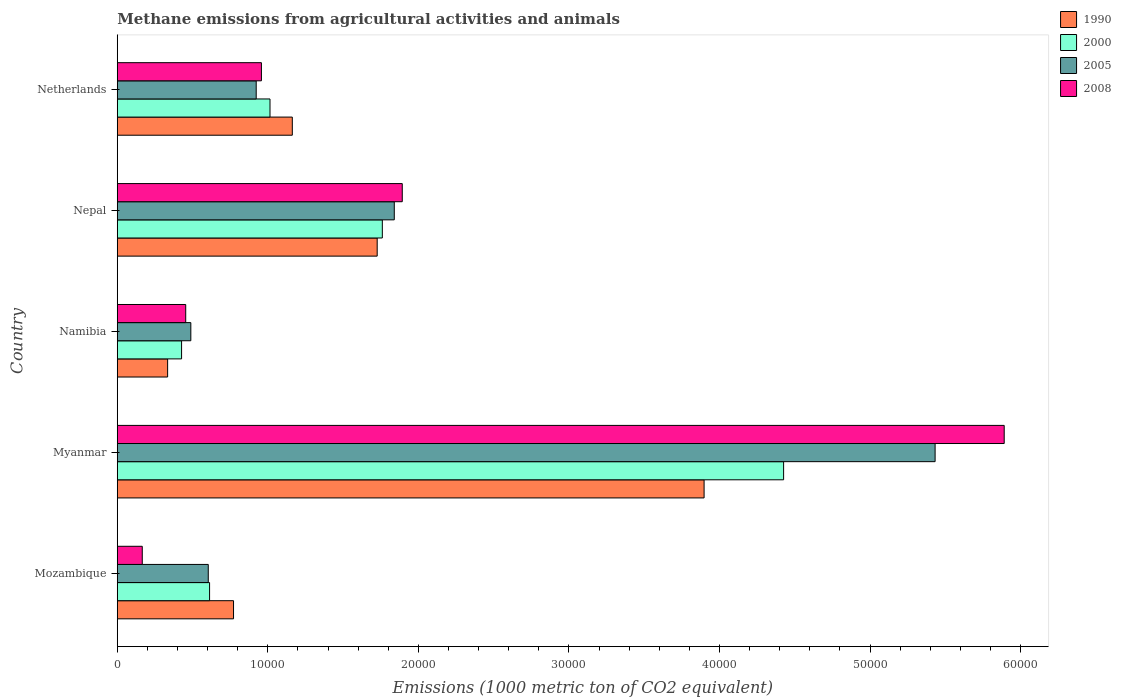How many groups of bars are there?
Your answer should be compact. 5. Are the number of bars on each tick of the Y-axis equal?
Offer a terse response. Yes. How many bars are there on the 4th tick from the top?
Make the answer very short. 4. How many bars are there on the 2nd tick from the bottom?
Offer a terse response. 4. What is the label of the 4th group of bars from the top?
Make the answer very short. Myanmar. In how many cases, is the number of bars for a given country not equal to the number of legend labels?
Your answer should be very brief. 0. What is the amount of methane emitted in 2005 in Mozambique?
Make the answer very short. 6043.9. Across all countries, what is the maximum amount of methane emitted in 2005?
Your response must be concise. 5.43e+04. Across all countries, what is the minimum amount of methane emitted in 1990?
Your answer should be very brief. 3344.1. In which country was the amount of methane emitted in 1990 maximum?
Keep it short and to the point. Myanmar. In which country was the amount of methane emitted in 2008 minimum?
Provide a succinct answer. Mozambique. What is the total amount of methane emitted in 2005 in the graph?
Offer a very short reply. 9.29e+04. What is the difference between the amount of methane emitted in 2008 in Mozambique and that in Myanmar?
Make the answer very short. -5.73e+04. What is the difference between the amount of methane emitted in 2005 in Namibia and the amount of methane emitted in 2008 in Myanmar?
Your answer should be very brief. -5.40e+04. What is the average amount of methane emitted in 2000 per country?
Keep it short and to the point. 1.65e+04. What is the difference between the amount of methane emitted in 2008 and amount of methane emitted in 1990 in Mozambique?
Keep it short and to the point. -6062.1. In how many countries, is the amount of methane emitted in 2005 greater than 22000 1000 metric ton?
Provide a succinct answer. 1. What is the ratio of the amount of methane emitted in 1990 in Namibia to that in Netherlands?
Offer a terse response. 0.29. What is the difference between the highest and the second highest amount of methane emitted in 2005?
Provide a succinct answer. 3.59e+04. What is the difference between the highest and the lowest amount of methane emitted in 2008?
Offer a terse response. 5.73e+04. In how many countries, is the amount of methane emitted in 2000 greater than the average amount of methane emitted in 2000 taken over all countries?
Make the answer very short. 2. What does the 3rd bar from the top in Nepal represents?
Your answer should be compact. 2000. How many bars are there?
Offer a very short reply. 20. What is the difference between two consecutive major ticks on the X-axis?
Give a very brief answer. 10000. Are the values on the major ticks of X-axis written in scientific E-notation?
Ensure brevity in your answer.  No. Does the graph contain grids?
Give a very brief answer. No. How many legend labels are there?
Your answer should be very brief. 4. What is the title of the graph?
Provide a succinct answer. Methane emissions from agricultural activities and animals. What is the label or title of the X-axis?
Give a very brief answer. Emissions (1000 metric ton of CO2 equivalent). What is the label or title of the Y-axis?
Make the answer very short. Country. What is the Emissions (1000 metric ton of CO2 equivalent) in 1990 in Mozambique?
Give a very brief answer. 7721.4. What is the Emissions (1000 metric ton of CO2 equivalent) of 2000 in Mozambique?
Provide a short and direct response. 6130.9. What is the Emissions (1000 metric ton of CO2 equivalent) in 2005 in Mozambique?
Offer a very short reply. 6043.9. What is the Emissions (1000 metric ton of CO2 equivalent) in 2008 in Mozambique?
Provide a succinct answer. 1659.3. What is the Emissions (1000 metric ton of CO2 equivalent) in 1990 in Myanmar?
Your response must be concise. 3.90e+04. What is the Emissions (1000 metric ton of CO2 equivalent) in 2000 in Myanmar?
Make the answer very short. 4.43e+04. What is the Emissions (1000 metric ton of CO2 equivalent) in 2005 in Myanmar?
Ensure brevity in your answer.  5.43e+04. What is the Emissions (1000 metric ton of CO2 equivalent) in 2008 in Myanmar?
Ensure brevity in your answer.  5.89e+04. What is the Emissions (1000 metric ton of CO2 equivalent) in 1990 in Namibia?
Your answer should be compact. 3344.1. What is the Emissions (1000 metric ton of CO2 equivalent) in 2000 in Namibia?
Offer a terse response. 4271.2. What is the Emissions (1000 metric ton of CO2 equivalent) of 2005 in Namibia?
Your answer should be very brief. 4885.4. What is the Emissions (1000 metric ton of CO2 equivalent) of 2008 in Namibia?
Provide a short and direct response. 4545.9. What is the Emissions (1000 metric ton of CO2 equivalent) in 1990 in Nepal?
Your response must be concise. 1.73e+04. What is the Emissions (1000 metric ton of CO2 equivalent) in 2000 in Nepal?
Your response must be concise. 1.76e+04. What is the Emissions (1000 metric ton of CO2 equivalent) of 2005 in Nepal?
Your answer should be very brief. 1.84e+04. What is the Emissions (1000 metric ton of CO2 equivalent) of 2008 in Nepal?
Keep it short and to the point. 1.89e+04. What is the Emissions (1000 metric ton of CO2 equivalent) in 1990 in Netherlands?
Offer a very short reply. 1.16e+04. What is the Emissions (1000 metric ton of CO2 equivalent) in 2000 in Netherlands?
Offer a terse response. 1.01e+04. What is the Emissions (1000 metric ton of CO2 equivalent) of 2005 in Netherlands?
Provide a succinct answer. 9228. What is the Emissions (1000 metric ton of CO2 equivalent) in 2008 in Netherlands?
Make the answer very short. 9574.5. Across all countries, what is the maximum Emissions (1000 metric ton of CO2 equivalent) in 1990?
Ensure brevity in your answer.  3.90e+04. Across all countries, what is the maximum Emissions (1000 metric ton of CO2 equivalent) in 2000?
Keep it short and to the point. 4.43e+04. Across all countries, what is the maximum Emissions (1000 metric ton of CO2 equivalent) in 2005?
Your answer should be very brief. 5.43e+04. Across all countries, what is the maximum Emissions (1000 metric ton of CO2 equivalent) of 2008?
Make the answer very short. 5.89e+04. Across all countries, what is the minimum Emissions (1000 metric ton of CO2 equivalent) of 1990?
Provide a short and direct response. 3344.1. Across all countries, what is the minimum Emissions (1000 metric ton of CO2 equivalent) in 2000?
Offer a very short reply. 4271.2. Across all countries, what is the minimum Emissions (1000 metric ton of CO2 equivalent) in 2005?
Keep it short and to the point. 4885.4. Across all countries, what is the minimum Emissions (1000 metric ton of CO2 equivalent) of 2008?
Your response must be concise. 1659.3. What is the total Emissions (1000 metric ton of CO2 equivalent) in 1990 in the graph?
Make the answer very short. 7.89e+04. What is the total Emissions (1000 metric ton of CO2 equivalent) in 2000 in the graph?
Provide a succinct answer. 8.24e+04. What is the total Emissions (1000 metric ton of CO2 equivalent) of 2005 in the graph?
Offer a terse response. 9.29e+04. What is the total Emissions (1000 metric ton of CO2 equivalent) of 2008 in the graph?
Keep it short and to the point. 9.36e+04. What is the difference between the Emissions (1000 metric ton of CO2 equivalent) in 1990 in Mozambique and that in Myanmar?
Your response must be concise. -3.13e+04. What is the difference between the Emissions (1000 metric ton of CO2 equivalent) of 2000 in Mozambique and that in Myanmar?
Your answer should be compact. -3.81e+04. What is the difference between the Emissions (1000 metric ton of CO2 equivalent) in 2005 in Mozambique and that in Myanmar?
Make the answer very short. -4.83e+04. What is the difference between the Emissions (1000 metric ton of CO2 equivalent) of 2008 in Mozambique and that in Myanmar?
Provide a succinct answer. -5.73e+04. What is the difference between the Emissions (1000 metric ton of CO2 equivalent) of 1990 in Mozambique and that in Namibia?
Offer a terse response. 4377.3. What is the difference between the Emissions (1000 metric ton of CO2 equivalent) of 2000 in Mozambique and that in Namibia?
Your answer should be compact. 1859.7. What is the difference between the Emissions (1000 metric ton of CO2 equivalent) in 2005 in Mozambique and that in Namibia?
Provide a short and direct response. 1158.5. What is the difference between the Emissions (1000 metric ton of CO2 equivalent) of 2008 in Mozambique and that in Namibia?
Your answer should be very brief. -2886.6. What is the difference between the Emissions (1000 metric ton of CO2 equivalent) of 1990 in Mozambique and that in Nepal?
Give a very brief answer. -9542.8. What is the difference between the Emissions (1000 metric ton of CO2 equivalent) in 2000 in Mozambique and that in Nepal?
Offer a very short reply. -1.15e+04. What is the difference between the Emissions (1000 metric ton of CO2 equivalent) of 2005 in Mozambique and that in Nepal?
Provide a succinct answer. -1.24e+04. What is the difference between the Emissions (1000 metric ton of CO2 equivalent) in 2008 in Mozambique and that in Nepal?
Your answer should be very brief. -1.73e+04. What is the difference between the Emissions (1000 metric ton of CO2 equivalent) in 1990 in Mozambique and that in Netherlands?
Your answer should be very brief. -3904.6. What is the difference between the Emissions (1000 metric ton of CO2 equivalent) of 2000 in Mozambique and that in Netherlands?
Keep it short and to the point. -4013.9. What is the difference between the Emissions (1000 metric ton of CO2 equivalent) in 2005 in Mozambique and that in Netherlands?
Provide a succinct answer. -3184.1. What is the difference between the Emissions (1000 metric ton of CO2 equivalent) in 2008 in Mozambique and that in Netherlands?
Provide a succinct answer. -7915.2. What is the difference between the Emissions (1000 metric ton of CO2 equivalent) of 1990 in Myanmar and that in Namibia?
Offer a terse response. 3.56e+04. What is the difference between the Emissions (1000 metric ton of CO2 equivalent) of 2000 in Myanmar and that in Namibia?
Give a very brief answer. 4.00e+04. What is the difference between the Emissions (1000 metric ton of CO2 equivalent) in 2005 in Myanmar and that in Namibia?
Keep it short and to the point. 4.94e+04. What is the difference between the Emissions (1000 metric ton of CO2 equivalent) in 2008 in Myanmar and that in Namibia?
Keep it short and to the point. 5.44e+04. What is the difference between the Emissions (1000 metric ton of CO2 equivalent) in 1990 in Myanmar and that in Nepal?
Keep it short and to the point. 2.17e+04. What is the difference between the Emissions (1000 metric ton of CO2 equivalent) of 2000 in Myanmar and that in Nepal?
Give a very brief answer. 2.67e+04. What is the difference between the Emissions (1000 metric ton of CO2 equivalent) in 2005 in Myanmar and that in Nepal?
Provide a short and direct response. 3.59e+04. What is the difference between the Emissions (1000 metric ton of CO2 equivalent) of 2008 in Myanmar and that in Nepal?
Provide a succinct answer. 4.00e+04. What is the difference between the Emissions (1000 metric ton of CO2 equivalent) of 1990 in Myanmar and that in Netherlands?
Your answer should be very brief. 2.74e+04. What is the difference between the Emissions (1000 metric ton of CO2 equivalent) of 2000 in Myanmar and that in Netherlands?
Your answer should be compact. 3.41e+04. What is the difference between the Emissions (1000 metric ton of CO2 equivalent) of 2005 in Myanmar and that in Netherlands?
Offer a very short reply. 4.51e+04. What is the difference between the Emissions (1000 metric ton of CO2 equivalent) of 2008 in Myanmar and that in Netherlands?
Offer a very short reply. 4.93e+04. What is the difference between the Emissions (1000 metric ton of CO2 equivalent) of 1990 in Namibia and that in Nepal?
Your answer should be compact. -1.39e+04. What is the difference between the Emissions (1000 metric ton of CO2 equivalent) of 2000 in Namibia and that in Nepal?
Offer a terse response. -1.33e+04. What is the difference between the Emissions (1000 metric ton of CO2 equivalent) in 2005 in Namibia and that in Nepal?
Offer a very short reply. -1.35e+04. What is the difference between the Emissions (1000 metric ton of CO2 equivalent) of 2008 in Namibia and that in Nepal?
Provide a short and direct response. -1.44e+04. What is the difference between the Emissions (1000 metric ton of CO2 equivalent) in 1990 in Namibia and that in Netherlands?
Keep it short and to the point. -8281.9. What is the difference between the Emissions (1000 metric ton of CO2 equivalent) in 2000 in Namibia and that in Netherlands?
Provide a succinct answer. -5873.6. What is the difference between the Emissions (1000 metric ton of CO2 equivalent) in 2005 in Namibia and that in Netherlands?
Offer a terse response. -4342.6. What is the difference between the Emissions (1000 metric ton of CO2 equivalent) of 2008 in Namibia and that in Netherlands?
Provide a succinct answer. -5028.6. What is the difference between the Emissions (1000 metric ton of CO2 equivalent) in 1990 in Nepal and that in Netherlands?
Ensure brevity in your answer.  5638.2. What is the difference between the Emissions (1000 metric ton of CO2 equivalent) in 2000 in Nepal and that in Netherlands?
Provide a short and direct response. 7461.2. What is the difference between the Emissions (1000 metric ton of CO2 equivalent) of 2005 in Nepal and that in Netherlands?
Offer a terse response. 9171.3. What is the difference between the Emissions (1000 metric ton of CO2 equivalent) in 2008 in Nepal and that in Netherlands?
Provide a short and direct response. 9355.9. What is the difference between the Emissions (1000 metric ton of CO2 equivalent) in 1990 in Mozambique and the Emissions (1000 metric ton of CO2 equivalent) in 2000 in Myanmar?
Provide a succinct answer. -3.65e+04. What is the difference between the Emissions (1000 metric ton of CO2 equivalent) in 1990 in Mozambique and the Emissions (1000 metric ton of CO2 equivalent) in 2005 in Myanmar?
Your answer should be compact. -4.66e+04. What is the difference between the Emissions (1000 metric ton of CO2 equivalent) in 1990 in Mozambique and the Emissions (1000 metric ton of CO2 equivalent) in 2008 in Myanmar?
Your response must be concise. -5.12e+04. What is the difference between the Emissions (1000 metric ton of CO2 equivalent) of 2000 in Mozambique and the Emissions (1000 metric ton of CO2 equivalent) of 2005 in Myanmar?
Keep it short and to the point. -4.82e+04. What is the difference between the Emissions (1000 metric ton of CO2 equivalent) of 2000 in Mozambique and the Emissions (1000 metric ton of CO2 equivalent) of 2008 in Myanmar?
Ensure brevity in your answer.  -5.28e+04. What is the difference between the Emissions (1000 metric ton of CO2 equivalent) in 2005 in Mozambique and the Emissions (1000 metric ton of CO2 equivalent) in 2008 in Myanmar?
Offer a very short reply. -5.29e+04. What is the difference between the Emissions (1000 metric ton of CO2 equivalent) in 1990 in Mozambique and the Emissions (1000 metric ton of CO2 equivalent) in 2000 in Namibia?
Keep it short and to the point. 3450.2. What is the difference between the Emissions (1000 metric ton of CO2 equivalent) in 1990 in Mozambique and the Emissions (1000 metric ton of CO2 equivalent) in 2005 in Namibia?
Keep it short and to the point. 2836. What is the difference between the Emissions (1000 metric ton of CO2 equivalent) in 1990 in Mozambique and the Emissions (1000 metric ton of CO2 equivalent) in 2008 in Namibia?
Your answer should be compact. 3175.5. What is the difference between the Emissions (1000 metric ton of CO2 equivalent) in 2000 in Mozambique and the Emissions (1000 metric ton of CO2 equivalent) in 2005 in Namibia?
Give a very brief answer. 1245.5. What is the difference between the Emissions (1000 metric ton of CO2 equivalent) of 2000 in Mozambique and the Emissions (1000 metric ton of CO2 equivalent) of 2008 in Namibia?
Give a very brief answer. 1585. What is the difference between the Emissions (1000 metric ton of CO2 equivalent) in 2005 in Mozambique and the Emissions (1000 metric ton of CO2 equivalent) in 2008 in Namibia?
Your response must be concise. 1498. What is the difference between the Emissions (1000 metric ton of CO2 equivalent) in 1990 in Mozambique and the Emissions (1000 metric ton of CO2 equivalent) in 2000 in Nepal?
Give a very brief answer. -9884.6. What is the difference between the Emissions (1000 metric ton of CO2 equivalent) in 1990 in Mozambique and the Emissions (1000 metric ton of CO2 equivalent) in 2005 in Nepal?
Provide a succinct answer. -1.07e+04. What is the difference between the Emissions (1000 metric ton of CO2 equivalent) in 1990 in Mozambique and the Emissions (1000 metric ton of CO2 equivalent) in 2008 in Nepal?
Make the answer very short. -1.12e+04. What is the difference between the Emissions (1000 metric ton of CO2 equivalent) in 2000 in Mozambique and the Emissions (1000 metric ton of CO2 equivalent) in 2005 in Nepal?
Provide a succinct answer. -1.23e+04. What is the difference between the Emissions (1000 metric ton of CO2 equivalent) in 2000 in Mozambique and the Emissions (1000 metric ton of CO2 equivalent) in 2008 in Nepal?
Provide a succinct answer. -1.28e+04. What is the difference between the Emissions (1000 metric ton of CO2 equivalent) in 2005 in Mozambique and the Emissions (1000 metric ton of CO2 equivalent) in 2008 in Nepal?
Ensure brevity in your answer.  -1.29e+04. What is the difference between the Emissions (1000 metric ton of CO2 equivalent) in 1990 in Mozambique and the Emissions (1000 metric ton of CO2 equivalent) in 2000 in Netherlands?
Your answer should be compact. -2423.4. What is the difference between the Emissions (1000 metric ton of CO2 equivalent) of 1990 in Mozambique and the Emissions (1000 metric ton of CO2 equivalent) of 2005 in Netherlands?
Your response must be concise. -1506.6. What is the difference between the Emissions (1000 metric ton of CO2 equivalent) in 1990 in Mozambique and the Emissions (1000 metric ton of CO2 equivalent) in 2008 in Netherlands?
Your response must be concise. -1853.1. What is the difference between the Emissions (1000 metric ton of CO2 equivalent) in 2000 in Mozambique and the Emissions (1000 metric ton of CO2 equivalent) in 2005 in Netherlands?
Provide a succinct answer. -3097.1. What is the difference between the Emissions (1000 metric ton of CO2 equivalent) in 2000 in Mozambique and the Emissions (1000 metric ton of CO2 equivalent) in 2008 in Netherlands?
Your answer should be very brief. -3443.6. What is the difference between the Emissions (1000 metric ton of CO2 equivalent) in 2005 in Mozambique and the Emissions (1000 metric ton of CO2 equivalent) in 2008 in Netherlands?
Your response must be concise. -3530.6. What is the difference between the Emissions (1000 metric ton of CO2 equivalent) of 1990 in Myanmar and the Emissions (1000 metric ton of CO2 equivalent) of 2000 in Namibia?
Give a very brief answer. 3.47e+04. What is the difference between the Emissions (1000 metric ton of CO2 equivalent) in 1990 in Myanmar and the Emissions (1000 metric ton of CO2 equivalent) in 2005 in Namibia?
Your answer should be very brief. 3.41e+04. What is the difference between the Emissions (1000 metric ton of CO2 equivalent) in 1990 in Myanmar and the Emissions (1000 metric ton of CO2 equivalent) in 2008 in Namibia?
Your answer should be very brief. 3.44e+04. What is the difference between the Emissions (1000 metric ton of CO2 equivalent) of 2000 in Myanmar and the Emissions (1000 metric ton of CO2 equivalent) of 2005 in Namibia?
Provide a short and direct response. 3.94e+04. What is the difference between the Emissions (1000 metric ton of CO2 equivalent) in 2000 in Myanmar and the Emissions (1000 metric ton of CO2 equivalent) in 2008 in Namibia?
Your response must be concise. 3.97e+04. What is the difference between the Emissions (1000 metric ton of CO2 equivalent) of 2005 in Myanmar and the Emissions (1000 metric ton of CO2 equivalent) of 2008 in Namibia?
Make the answer very short. 4.98e+04. What is the difference between the Emissions (1000 metric ton of CO2 equivalent) in 1990 in Myanmar and the Emissions (1000 metric ton of CO2 equivalent) in 2000 in Nepal?
Ensure brevity in your answer.  2.14e+04. What is the difference between the Emissions (1000 metric ton of CO2 equivalent) in 1990 in Myanmar and the Emissions (1000 metric ton of CO2 equivalent) in 2005 in Nepal?
Offer a very short reply. 2.06e+04. What is the difference between the Emissions (1000 metric ton of CO2 equivalent) of 1990 in Myanmar and the Emissions (1000 metric ton of CO2 equivalent) of 2008 in Nepal?
Provide a succinct answer. 2.00e+04. What is the difference between the Emissions (1000 metric ton of CO2 equivalent) of 2000 in Myanmar and the Emissions (1000 metric ton of CO2 equivalent) of 2005 in Nepal?
Offer a terse response. 2.59e+04. What is the difference between the Emissions (1000 metric ton of CO2 equivalent) in 2000 in Myanmar and the Emissions (1000 metric ton of CO2 equivalent) in 2008 in Nepal?
Your response must be concise. 2.53e+04. What is the difference between the Emissions (1000 metric ton of CO2 equivalent) in 2005 in Myanmar and the Emissions (1000 metric ton of CO2 equivalent) in 2008 in Nepal?
Provide a short and direct response. 3.54e+04. What is the difference between the Emissions (1000 metric ton of CO2 equivalent) of 1990 in Myanmar and the Emissions (1000 metric ton of CO2 equivalent) of 2000 in Netherlands?
Offer a terse response. 2.88e+04. What is the difference between the Emissions (1000 metric ton of CO2 equivalent) in 1990 in Myanmar and the Emissions (1000 metric ton of CO2 equivalent) in 2005 in Netherlands?
Your answer should be very brief. 2.98e+04. What is the difference between the Emissions (1000 metric ton of CO2 equivalent) in 1990 in Myanmar and the Emissions (1000 metric ton of CO2 equivalent) in 2008 in Netherlands?
Give a very brief answer. 2.94e+04. What is the difference between the Emissions (1000 metric ton of CO2 equivalent) in 2000 in Myanmar and the Emissions (1000 metric ton of CO2 equivalent) in 2005 in Netherlands?
Offer a very short reply. 3.50e+04. What is the difference between the Emissions (1000 metric ton of CO2 equivalent) of 2000 in Myanmar and the Emissions (1000 metric ton of CO2 equivalent) of 2008 in Netherlands?
Make the answer very short. 3.47e+04. What is the difference between the Emissions (1000 metric ton of CO2 equivalent) of 2005 in Myanmar and the Emissions (1000 metric ton of CO2 equivalent) of 2008 in Netherlands?
Offer a very short reply. 4.47e+04. What is the difference between the Emissions (1000 metric ton of CO2 equivalent) in 1990 in Namibia and the Emissions (1000 metric ton of CO2 equivalent) in 2000 in Nepal?
Your response must be concise. -1.43e+04. What is the difference between the Emissions (1000 metric ton of CO2 equivalent) in 1990 in Namibia and the Emissions (1000 metric ton of CO2 equivalent) in 2005 in Nepal?
Provide a succinct answer. -1.51e+04. What is the difference between the Emissions (1000 metric ton of CO2 equivalent) of 1990 in Namibia and the Emissions (1000 metric ton of CO2 equivalent) of 2008 in Nepal?
Offer a terse response. -1.56e+04. What is the difference between the Emissions (1000 metric ton of CO2 equivalent) in 2000 in Namibia and the Emissions (1000 metric ton of CO2 equivalent) in 2005 in Nepal?
Ensure brevity in your answer.  -1.41e+04. What is the difference between the Emissions (1000 metric ton of CO2 equivalent) in 2000 in Namibia and the Emissions (1000 metric ton of CO2 equivalent) in 2008 in Nepal?
Make the answer very short. -1.47e+04. What is the difference between the Emissions (1000 metric ton of CO2 equivalent) in 2005 in Namibia and the Emissions (1000 metric ton of CO2 equivalent) in 2008 in Nepal?
Offer a terse response. -1.40e+04. What is the difference between the Emissions (1000 metric ton of CO2 equivalent) of 1990 in Namibia and the Emissions (1000 metric ton of CO2 equivalent) of 2000 in Netherlands?
Give a very brief answer. -6800.7. What is the difference between the Emissions (1000 metric ton of CO2 equivalent) in 1990 in Namibia and the Emissions (1000 metric ton of CO2 equivalent) in 2005 in Netherlands?
Your answer should be very brief. -5883.9. What is the difference between the Emissions (1000 metric ton of CO2 equivalent) of 1990 in Namibia and the Emissions (1000 metric ton of CO2 equivalent) of 2008 in Netherlands?
Make the answer very short. -6230.4. What is the difference between the Emissions (1000 metric ton of CO2 equivalent) of 2000 in Namibia and the Emissions (1000 metric ton of CO2 equivalent) of 2005 in Netherlands?
Offer a terse response. -4956.8. What is the difference between the Emissions (1000 metric ton of CO2 equivalent) in 2000 in Namibia and the Emissions (1000 metric ton of CO2 equivalent) in 2008 in Netherlands?
Offer a terse response. -5303.3. What is the difference between the Emissions (1000 metric ton of CO2 equivalent) in 2005 in Namibia and the Emissions (1000 metric ton of CO2 equivalent) in 2008 in Netherlands?
Offer a very short reply. -4689.1. What is the difference between the Emissions (1000 metric ton of CO2 equivalent) of 1990 in Nepal and the Emissions (1000 metric ton of CO2 equivalent) of 2000 in Netherlands?
Offer a very short reply. 7119.4. What is the difference between the Emissions (1000 metric ton of CO2 equivalent) of 1990 in Nepal and the Emissions (1000 metric ton of CO2 equivalent) of 2005 in Netherlands?
Provide a short and direct response. 8036.2. What is the difference between the Emissions (1000 metric ton of CO2 equivalent) of 1990 in Nepal and the Emissions (1000 metric ton of CO2 equivalent) of 2008 in Netherlands?
Give a very brief answer. 7689.7. What is the difference between the Emissions (1000 metric ton of CO2 equivalent) in 2000 in Nepal and the Emissions (1000 metric ton of CO2 equivalent) in 2005 in Netherlands?
Ensure brevity in your answer.  8378. What is the difference between the Emissions (1000 metric ton of CO2 equivalent) of 2000 in Nepal and the Emissions (1000 metric ton of CO2 equivalent) of 2008 in Netherlands?
Provide a short and direct response. 8031.5. What is the difference between the Emissions (1000 metric ton of CO2 equivalent) of 2005 in Nepal and the Emissions (1000 metric ton of CO2 equivalent) of 2008 in Netherlands?
Offer a terse response. 8824.8. What is the average Emissions (1000 metric ton of CO2 equivalent) in 1990 per country?
Your answer should be very brief. 1.58e+04. What is the average Emissions (1000 metric ton of CO2 equivalent) in 2000 per country?
Ensure brevity in your answer.  1.65e+04. What is the average Emissions (1000 metric ton of CO2 equivalent) in 2005 per country?
Make the answer very short. 1.86e+04. What is the average Emissions (1000 metric ton of CO2 equivalent) in 2008 per country?
Give a very brief answer. 1.87e+04. What is the difference between the Emissions (1000 metric ton of CO2 equivalent) in 1990 and Emissions (1000 metric ton of CO2 equivalent) in 2000 in Mozambique?
Offer a terse response. 1590.5. What is the difference between the Emissions (1000 metric ton of CO2 equivalent) of 1990 and Emissions (1000 metric ton of CO2 equivalent) of 2005 in Mozambique?
Offer a terse response. 1677.5. What is the difference between the Emissions (1000 metric ton of CO2 equivalent) in 1990 and Emissions (1000 metric ton of CO2 equivalent) in 2008 in Mozambique?
Provide a succinct answer. 6062.1. What is the difference between the Emissions (1000 metric ton of CO2 equivalent) of 2000 and Emissions (1000 metric ton of CO2 equivalent) of 2008 in Mozambique?
Provide a succinct answer. 4471.6. What is the difference between the Emissions (1000 metric ton of CO2 equivalent) of 2005 and Emissions (1000 metric ton of CO2 equivalent) of 2008 in Mozambique?
Your answer should be very brief. 4384.6. What is the difference between the Emissions (1000 metric ton of CO2 equivalent) of 1990 and Emissions (1000 metric ton of CO2 equivalent) of 2000 in Myanmar?
Make the answer very short. -5282. What is the difference between the Emissions (1000 metric ton of CO2 equivalent) of 1990 and Emissions (1000 metric ton of CO2 equivalent) of 2005 in Myanmar?
Give a very brief answer. -1.53e+04. What is the difference between the Emissions (1000 metric ton of CO2 equivalent) in 1990 and Emissions (1000 metric ton of CO2 equivalent) in 2008 in Myanmar?
Offer a terse response. -1.99e+04. What is the difference between the Emissions (1000 metric ton of CO2 equivalent) of 2000 and Emissions (1000 metric ton of CO2 equivalent) of 2005 in Myanmar?
Your answer should be very brief. -1.01e+04. What is the difference between the Emissions (1000 metric ton of CO2 equivalent) in 2000 and Emissions (1000 metric ton of CO2 equivalent) in 2008 in Myanmar?
Your response must be concise. -1.47e+04. What is the difference between the Emissions (1000 metric ton of CO2 equivalent) of 2005 and Emissions (1000 metric ton of CO2 equivalent) of 2008 in Myanmar?
Keep it short and to the point. -4589.9. What is the difference between the Emissions (1000 metric ton of CO2 equivalent) in 1990 and Emissions (1000 metric ton of CO2 equivalent) in 2000 in Namibia?
Make the answer very short. -927.1. What is the difference between the Emissions (1000 metric ton of CO2 equivalent) in 1990 and Emissions (1000 metric ton of CO2 equivalent) in 2005 in Namibia?
Keep it short and to the point. -1541.3. What is the difference between the Emissions (1000 metric ton of CO2 equivalent) of 1990 and Emissions (1000 metric ton of CO2 equivalent) of 2008 in Namibia?
Offer a terse response. -1201.8. What is the difference between the Emissions (1000 metric ton of CO2 equivalent) of 2000 and Emissions (1000 metric ton of CO2 equivalent) of 2005 in Namibia?
Offer a very short reply. -614.2. What is the difference between the Emissions (1000 metric ton of CO2 equivalent) in 2000 and Emissions (1000 metric ton of CO2 equivalent) in 2008 in Namibia?
Make the answer very short. -274.7. What is the difference between the Emissions (1000 metric ton of CO2 equivalent) in 2005 and Emissions (1000 metric ton of CO2 equivalent) in 2008 in Namibia?
Provide a succinct answer. 339.5. What is the difference between the Emissions (1000 metric ton of CO2 equivalent) of 1990 and Emissions (1000 metric ton of CO2 equivalent) of 2000 in Nepal?
Your answer should be very brief. -341.8. What is the difference between the Emissions (1000 metric ton of CO2 equivalent) of 1990 and Emissions (1000 metric ton of CO2 equivalent) of 2005 in Nepal?
Make the answer very short. -1135.1. What is the difference between the Emissions (1000 metric ton of CO2 equivalent) of 1990 and Emissions (1000 metric ton of CO2 equivalent) of 2008 in Nepal?
Offer a terse response. -1666.2. What is the difference between the Emissions (1000 metric ton of CO2 equivalent) in 2000 and Emissions (1000 metric ton of CO2 equivalent) in 2005 in Nepal?
Provide a succinct answer. -793.3. What is the difference between the Emissions (1000 metric ton of CO2 equivalent) in 2000 and Emissions (1000 metric ton of CO2 equivalent) in 2008 in Nepal?
Offer a very short reply. -1324.4. What is the difference between the Emissions (1000 metric ton of CO2 equivalent) in 2005 and Emissions (1000 metric ton of CO2 equivalent) in 2008 in Nepal?
Make the answer very short. -531.1. What is the difference between the Emissions (1000 metric ton of CO2 equivalent) in 1990 and Emissions (1000 metric ton of CO2 equivalent) in 2000 in Netherlands?
Your answer should be compact. 1481.2. What is the difference between the Emissions (1000 metric ton of CO2 equivalent) in 1990 and Emissions (1000 metric ton of CO2 equivalent) in 2005 in Netherlands?
Offer a terse response. 2398. What is the difference between the Emissions (1000 metric ton of CO2 equivalent) of 1990 and Emissions (1000 metric ton of CO2 equivalent) of 2008 in Netherlands?
Offer a very short reply. 2051.5. What is the difference between the Emissions (1000 metric ton of CO2 equivalent) in 2000 and Emissions (1000 metric ton of CO2 equivalent) in 2005 in Netherlands?
Provide a short and direct response. 916.8. What is the difference between the Emissions (1000 metric ton of CO2 equivalent) in 2000 and Emissions (1000 metric ton of CO2 equivalent) in 2008 in Netherlands?
Offer a terse response. 570.3. What is the difference between the Emissions (1000 metric ton of CO2 equivalent) in 2005 and Emissions (1000 metric ton of CO2 equivalent) in 2008 in Netherlands?
Keep it short and to the point. -346.5. What is the ratio of the Emissions (1000 metric ton of CO2 equivalent) of 1990 in Mozambique to that in Myanmar?
Give a very brief answer. 0.2. What is the ratio of the Emissions (1000 metric ton of CO2 equivalent) of 2000 in Mozambique to that in Myanmar?
Ensure brevity in your answer.  0.14. What is the ratio of the Emissions (1000 metric ton of CO2 equivalent) of 2005 in Mozambique to that in Myanmar?
Ensure brevity in your answer.  0.11. What is the ratio of the Emissions (1000 metric ton of CO2 equivalent) in 2008 in Mozambique to that in Myanmar?
Offer a terse response. 0.03. What is the ratio of the Emissions (1000 metric ton of CO2 equivalent) of 1990 in Mozambique to that in Namibia?
Your response must be concise. 2.31. What is the ratio of the Emissions (1000 metric ton of CO2 equivalent) of 2000 in Mozambique to that in Namibia?
Provide a succinct answer. 1.44. What is the ratio of the Emissions (1000 metric ton of CO2 equivalent) in 2005 in Mozambique to that in Namibia?
Provide a succinct answer. 1.24. What is the ratio of the Emissions (1000 metric ton of CO2 equivalent) in 2008 in Mozambique to that in Namibia?
Your answer should be very brief. 0.36. What is the ratio of the Emissions (1000 metric ton of CO2 equivalent) of 1990 in Mozambique to that in Nepal?
Provide a short and direct response. 0.45. What is the ratio of the Emissions (1000 metric ton of CO2 equivalent) in 2000 in Mozambique to that in Nepal?
Keep it short and to the point. 0.35. What is the ratio of the Emissions (1000 metric ton of CO2 equivalent) in 2005 in Mozambique to that in Nepal?
Give a very brief answer. 0.33. What is the ratio of the Emissions (1000 metric ton of CO2 equivalent) of 2008 in Mozambique to that in Nepal?
Give a very brief answer. 0.09. What is the ratio of the Emissions (1000 metric ton of CO2 equivalent) in 1990 in Mozambique to that in Netherlands?
Your answer should be very brief. 0.66. What is the ratio of the Emissions (1000 metric ton of CO2 equivalent) of 2000 in Mozambique to that in Netherlands?
Make the answer very short. 0.6. What is the ratio of the Emissions (1000 metric ton of CO2 equivalent) of 2005 in Mozambique to that in Netherlands?
Keep it short and to the point. 0.66. What is the ratio of the Emissions (1000 metric ton of CO2 equivalent) in 2008 in Mozambique to that in Netherlands?
Make the answer very short. 0.17. What is the ratio of the Emissions (1000 metric ton of CO2 equivalent) of 1990 in Myanmar to that in Namibia?
Provide a short and direct response. 11.66. What is the ratio of the Emissions (1000 metric ton of CO2 equivalent) of 2000 in Myanmar to that in Namibia?
Your answer should be very brief. 10.36. What is the ratio of the Emissions (1000 metric ton of CO2 equivalent) in 2005 in Myanmar to that in Namibia?
Provide a succinct answer. 11.12. What is the ratio of the Emissions (1000 metric ton of CO2 equivalent) in 2008 in Myanmar to that in Namibia?
Give a very brief answer. 12.96. What is the ratio of the Emissions (1000 metric ton of CO2 equivalent) in 1990 in Myanmar to that in Nepal?
Offer a terse response. 2.26. What is the ratio of the Emissions (1000 metric ton of CO2 equivalent) in 2000 in Myanmar to that in Nepal?
Make the answer very short. 2.51. What is the ratio of the Emissions (1000 metric ton of CO2 equivalent) in 2005 in Myanmar to that in Nepal?
Your answer should be very brief. 2.95. What is the ratio of the Emissions (1000 metric ton of CO2 equivalent) in 2008 in Myanmar to that in Nepal?
Offer a terse response. 3.11. What is the ratio of the Emissions (1000 metric ton of CO2 equivalent) in 1990 in Myanmar to that in Netherlands?
Provide a short and direct response. 3.35. What is the ratio of the Emissions (1000 metric ton of CO2 equivalent) of 2000 in Myanmar to that in Netherlands?
Keep it short and to the point. 4.36. What is the ratio of the Emissions (1000 metric ton of CO2 equivalent) in 2005 in Myanmar to that in Netherlands?
Offer a very short reply. 5.89. What is the ratio of the Emissions (1000 metric ton of CO2 equivalent) of 2008 in Myanmar to that in Netherlands?
Ensure brevity in your answer.  6.15. What is the ratio of the Emissions (1000 metric ton of CO2 equivalent) of 1990 in Namibia to that in Nepal?
Offer a terse response. 0.19. What is the ratio of the Emissions (1000 metric ton of CO2 equivalent) of 2000 in Namibia to that in Nepal?
Your answer should be compact. 0.24. What is the ratio of the Emissions (1000 metric ton of CO2 equivalent) in 2005 in Namibia to that in Nepal?
Make the answer very short. 0.27. What is the ratio of the Emissions (1000 metric ton of CO2 equivalent) in 2008 in Namibia to that in Nepal?
Provide a short and direct response. 0.24. What is the ratio of the Emissions (1000 metric ton of CO2 equivalent) of 1990 in Namibia to that in Netherlands?
Your response must be concise. 0.29. What is the ratio of the Emissions (1000 metric ton of CO2 equivalent) in 2000 in Namibia to that in Netherlands?
Offer a very short reply. 0.42. What is the ratio of the Emissions (1000 metric ton of CO2 equivalent) of 2005 in Namibia to that in Netherlands?
Provide a succinct answer. 0.53. What is the ratio of the Emissions (1000 metric ton of CO2 equivalent) in 2008 in Namibia to that in Netherlands?
Ensure brevity in your answer.  0.47. What is the ratio of the Emissions (1000 metric ton of CO2 equivalent) of 1990 in Nepal to that in Netherlands?
Offer a very short reply. 1.49. What is the ratio of the Emissions (1000 metric ton of CO2 equivalent) in 2000 in Nepal to that in Netherlands?
Offer a very short reply. 1.74. What is the ratio of the Emissions (1000 metric ton of CO2 equivalent) in 2005 in Nepal to that in Netherlands?
Offer a terse response. 1.99. What is the ratio of the Emissions (1000 metric ton of CO2 equivalent) in 2008 in Nepal to that in Netherlands?
Provide a succinct answer. 1.98. What is the difference between the highest and the second highest Emissions (1000 metric ton of CO2 equivalent) in 1990?
Your answer should be very brief. 2.17e+04. What is the difference between the highest and the second highest Emissions (1000 metric ton of CO2 equivalent) in 2000?
Offer a terse response. 2.67e+04. What is the difference between the highest and the second highest Emissions (1000 metric ton of CO2 equivalent) of 2005?
Provide a succinct answer. 3.59e+04. What is the difference between the highest and the second highest Emissions (1000 metric ton of CO2 equivalent) in 2008?
Offer a very short reply. 4.00e+04. What is the difference between the highest and the lowest Emissions (1000 metric ton of CO2 equivalent) of 1990?
Offer a very short reply. 3.56e+04. What is the difference between the highest and the lowest Emissions (1000 metric ton of CO2 equivalent) in 2000?
Your answer should be compact. 4.00e+04. What is the difference between the highest and the lowest Emissions (1000 metric ton of CO2 equivalent) of 2005?
Provide a succinct answer. 4.94e+04. What is the difference between the highest and the lowest Emissions (1000 metric ton of CO2 equivalent) of 2008?
Provide a succinct answer. 5.73e+04. 